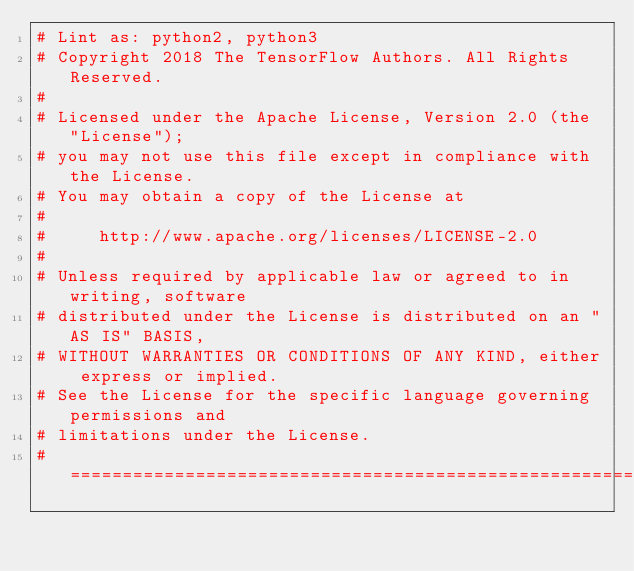Convert code to text. <code><loc_0><loc_0><loc_500><loc_500><_Python_># Lint as: python2, python3
# Copyright 2018 The TensorFlow Authors. All Rights Reserved.
#
# Licensed under the Apache License, Version 2.0 (the "License");
# you may not use this file except in compliance with the License.
# You may obtain a copy of the License at
#
#     http://www.apache.org/licenses/LICENSE-2.0
#
# Unless required by applicable law or agreed to in writing, software
# distributed under the License is distributed on an "AS IS" BASIS,
# WITHOUT WARRANTIES OR CONDITIONS OF ANY KIND, either express or implied.
# See the License for the specific language governing permissions and
# limitations under the License.
# ==============================================================================</code> 